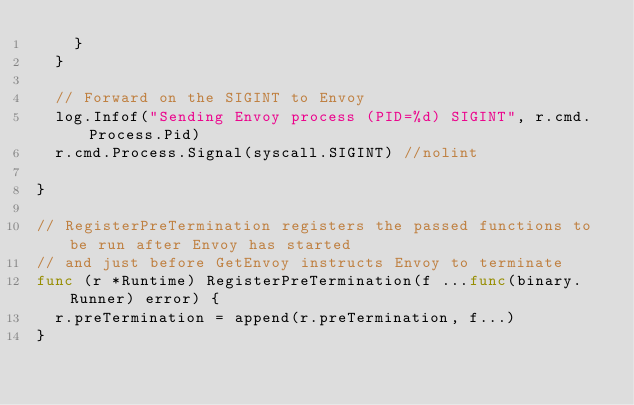Convert code to text. <code><loc_0><loc_0><loc_500><loc_500><_Go_>		}
	}

	// Forward on the SIGINT to Envoy
	log.Infof("Sending Envoy process (PID=%d) SIGINT", r.cmd.Process.Pid)
	r.cmd.Process.Signal(syscall.SIGINT) //nolint

}

// RegisterPreTermination registers the passed functions to be run after Envoy has started
// and just before GetEnvoy instructs Envoy to terminate
func (r *Runtime) RegisterPreTermination(f ...func(binary.Runner) error) {
	r.preTermination = append(r.preTermination, f...)
}
</code> 